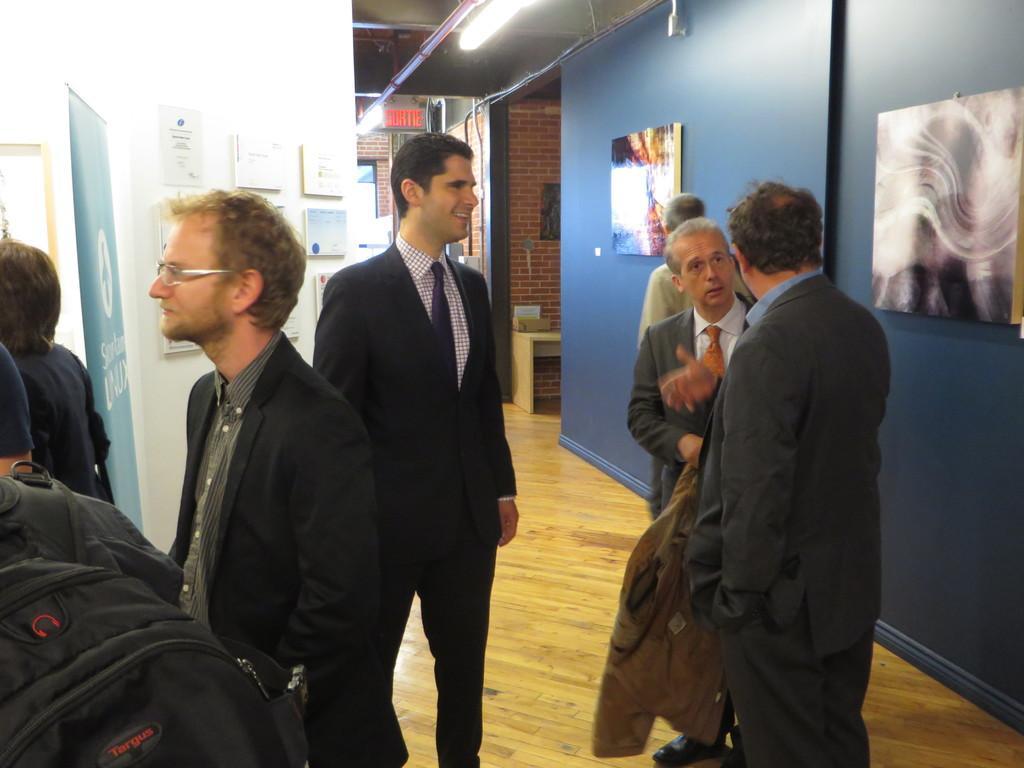In one or two sentences, can you explain what this image depicts? In this picture we can see frames, boards on the wall. At the top we can see lights. We can see people, standing and few are discussing and smiling. On the left side of the picture we can see a man wearing a backpack, board. At the bottom we can see the floor. Far near to the wall we can see an object placed on a table. 